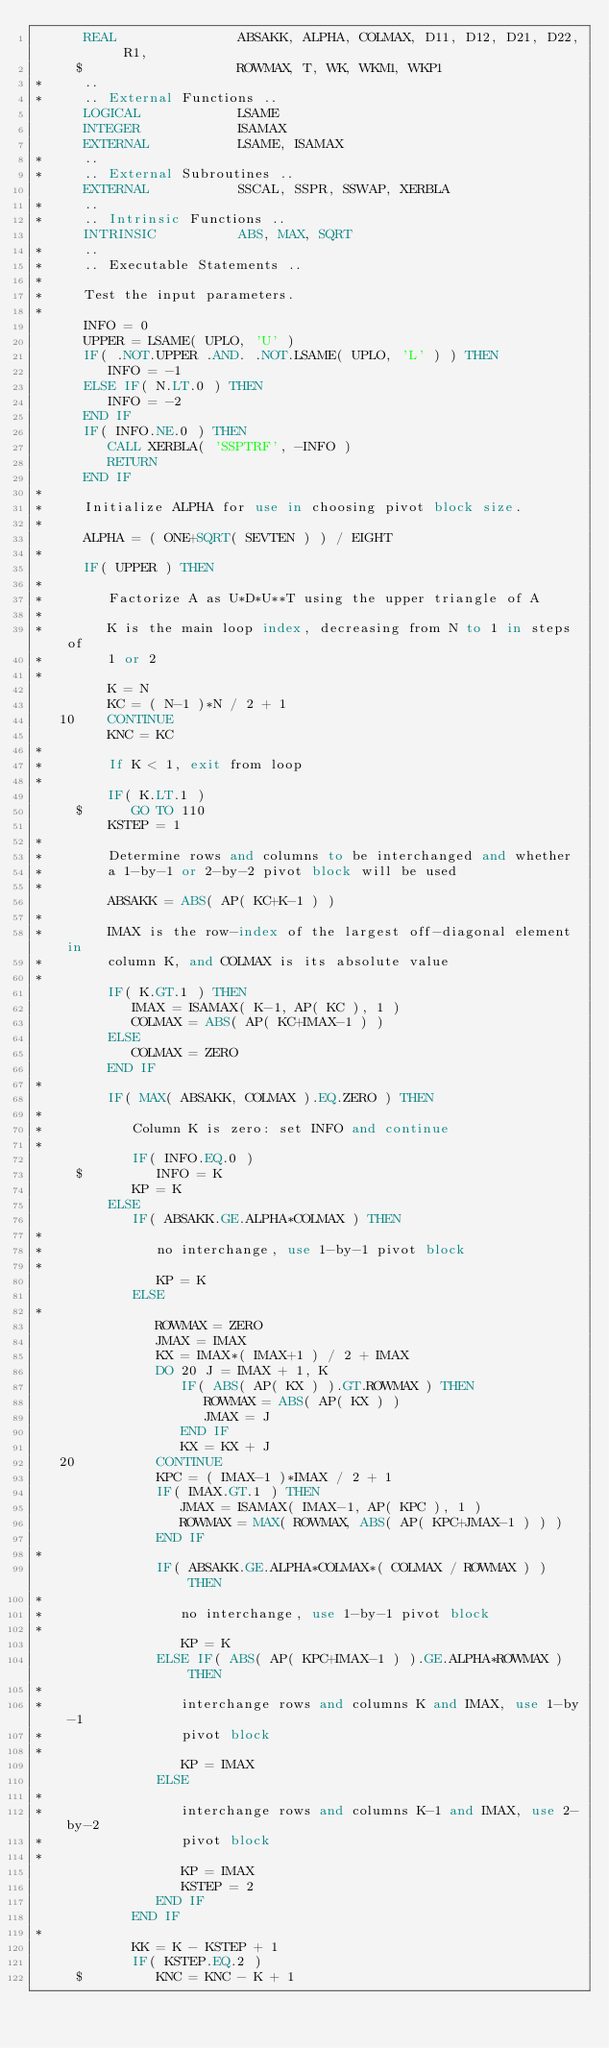<code> <loc_0><loc_0><loc_500><loc_500><_FORTRAN_>      REAL               ABSAKK, ALPHA, COLMAX, D11, D12, D21, D22, R1,
     $                   ROWMAX, T, WK, WKM1, WKP1
*     ..
*     .. External Functions ..
      LOGICAL            LSAME
      INTEGER            ISAMAX
      EXTERNAL           LSAME, ISAMAX
*     ..
*     .. External Subroutines ..
      EXTERNAL           SSCAL, SSPR, SSWAP, XERBLA
*     ..
*     .. Intrinsic Functions ..
      INTRINSIC          ABS, MAX, SQRT
*     ..
*     .. Executable Statements ..
*
*     Test the input parameters.
*
      INFO = 0
      UPPER = LSAME( UPLO, 'U' )
      IF( .NOT.UPPER .AND. .NOT.LSAME( UPLO, 'L' ) ) THEN
         INFO = -1
      ELSE IF( N.LT.0 ) THEN
         INFO = -2
      END IF
      IF( INFO.NE.0 ) THEN
         CALL XERBLA( 'SSPTRF', -INFO )
         RETURN
      END IF
*
*     Initialize ALPHA for use in choosing pivot block size.
*
      ALPHA = ( ONE+SQRT( SEVTEN ) ) / EIGHT
*
      IF( UPPER ) THEN
*
*        Factorize A as U*D*U**T using the upper triangle of A
*
*        K is the main loop index, decreasing from N to 1 in steps of
*        1 or 2
*
         K = N
         KC = ( N-1 )*N / 2 + 1
   10    CONTINUE
         KNC = KC
*
*        If K < 1, exit from loop
*
         IF( K.LT.1 )
     $      GO TO 110
         KSTEP = 1
*
*        Determine rows and columns to be interchanged and whether
*        a 1-by-1 or 2-by-2 pivot block will be used
*
         ABSAKK = ABS( AP( KC+K-1 ) )
*
*        IMAX is the row-index of the largest off-diagonal element in
*        column K, and COLMAX is its absolute value
*
         IF( K.GT.1 ) THEN
            IMAX = ISAMAX( K-1, AP( KC ), 1 )
            COLMAX = ABS( AP( KC+IMAX-1 ) )
         ELSE
            COLMAX = ZERO
         END IF
*
         IF( MAX( ABSAKK, COLMAX ).EQ.ZERO ) THEN
*
*           Column K is zero: set INFO and continue
*
            IF( INFO.EQ.0 )
     $         INFO = K
            KP = K
         ELSE
            IF( ABSAKK.GE.ALPHA*COLMAX ) THEN
*
*              no interchange, use 1-by-1 pivot block
*
               KP = K
            ELSE
*
               ROWMAX = ZERO
               JMAX = IMAX
               KX = IMAX*( IMAX+1 ) / 2 + IMAX
               DO 20 J = IMAX + 1, K
                  IF( ABS( AP( KX ) ).GT.ROWMAX ) THEN
                     ROWMAX = ABS( AP( KX ) )
                     JMAX = J
                  END IF
                  KX = KX + J
   20          CONTINUE
               KPC = ( IMAX-1 )*IMAX / 2 + 1
               IF( IMAX.GT.1 ) THEN
                  JMAX = ISAMAX( IMAX-1, AP( KPC ), 1 )
                  ROWMAX = MAX( ROWMAX, ABS( AP( KPC+JMAX-1 ) ) )
               END IF
*
               IF( ABSAKK.GE.ALPHA*COLMAX*( COLMAX / ROWMAX ) ) THEN
*
*                 no interchange, use 1-by-1 pivot block
*
                  KP = K
               ELSE IF( ABS( AP( KPC+IMAX-1 ) ).GE.ALPHA*ROWMAX ) THEN
*
*                 interchange rows and columns K and IMAX, use 1-by-1
*                 pivot block
*
                  KP = IMAX
               ELSE
*
*                 interchange rows and columns K-1 and IMAX, use 2-by-2
*                 pivot block
*
                  KP = IMAX
                  KSTEP = 2
               END IF
            END IF
*
            KK = K - KSTEP + 1
            IF( KSTEP.EQ.2 )
     $         KNC = KNC - K + 1</code> 